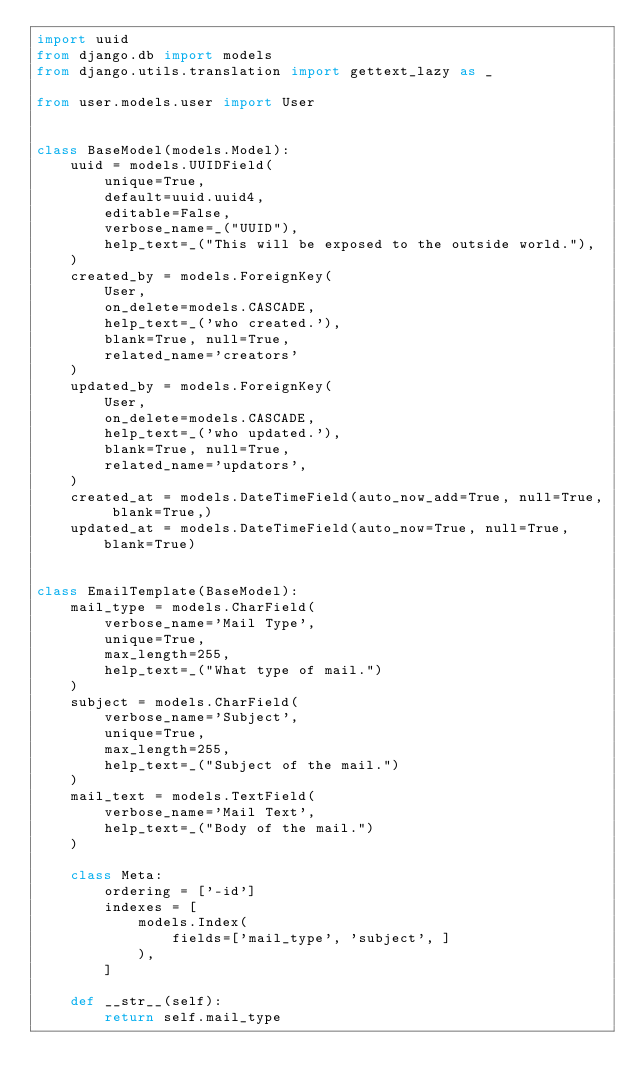Convert code to text. <code><loc_0><loc_0><loc_500><loc_500><_Python_>import uuid
from django.db import models
from django.utils.translation import gettext_lazy as _

from user.models.user import User


class BaseModel(models.Model):
    uuid = models.UUIDField(
        unique=True,
        default=uuid.uuid4,
        editable=False,
        verbose_name=_("UUID"),
        help_text=_("This will be exposed to the outside world."),
    )
    created_by = models.ForeignKey(
        User,
        on_delete=models.CASCADE,
        help_text=_('who created.'),
        blank=True, null=True,
        related_name='creators'
    )
    updated_by = models.ForeignKey(
        User,
        on_delete=models.CASCADE,
        help_text=_('who updated.'),
        blank=True, null=True,
        related_name='updators',
    )
    created_at = models.DateTimeField(auto_now_add=True, null=True, blank=True,)
    updated_at = models.DateTimeField(auto_now=True, null=True, blank=True)


class EmailTemplate(BaseModel):
    mail_type = models.CharField(
        verbose_name='Mail Type',
        unique=True,
        max_length=255,
        help_text=_("What type of mail.")
    )
    subject = models.CharField(
        verbose_name='Subject',
        unique=True,
        max_length=255,
        help_text=_("Subject of the mail.")
    )
    mail_text = models.TextField(
        verbose_name='Mail Text',
        help_text=_("Body of the mail.")
    )

    class Meta:
        ordering = ['-id']
        indexes = [
            models.Index(
                fields=['mail_type', 'subject', ]
            ),
        ]

    def __str__(self):
        return self.mail_type
</code> 